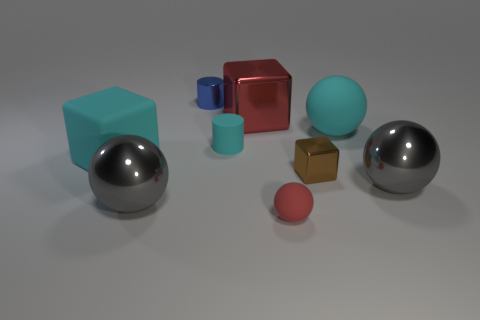What is the size of the ball that is the same color as the large rubber block?
Your response must be concise. Large. What is the shape of the object that is the same color as the tiny rubber ball?
Keep it short and to the point. Cube. Does the large metal object to the right of the red metal object have the same color as the sphere left of the small metallic cylinder?
Provide a succinct answer. Yes. Are there more small brown things behind the red metallic block than metal objects?
Your response must be concise. No. There is a block behind the cyan matte block; does it have the same size as the big rubber cube?
Your answer should be compact. Yes. What color is the rubber thing that is both right of the cyan rubber cube and in front of the rubber cylinder?
Provide a short and direct response. Red. The brown shiny thing that is the same size as the blue shiny thing is what shape?
Offer a terse response. Cube. Are there any large matte objects that have the same color as the large metal cube?
Your response must be concise. No. Are there an equal number of big matte cubes that are right of the tiny brown metal cube and small metal cylinders?
Provide a succinct answer. No. Does the rubber cube have the same color as the tiny rubber sphere?
Offer a very short reply. No. 